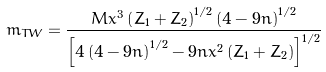<formula> <loc_0><loc_0><loc_500><loc_500>m _ { T W } = \frac { M x ^ { 3 } \left ( Z _ { 1 } + Z _ { 2 } \right ) ^ { 1 / 2 } \left ( 4 - 9 n \right ) ^ { 1 / 2 } } { \left [ 4 \left ( 4 - 9 n \right ) ^ { 1 / 2 } - 9 n x ^ { 2 } \left ( Z _ { 1 } + Z _ { 2 } \right ) \right ] ^ { 1 / 2 } }</formula> 